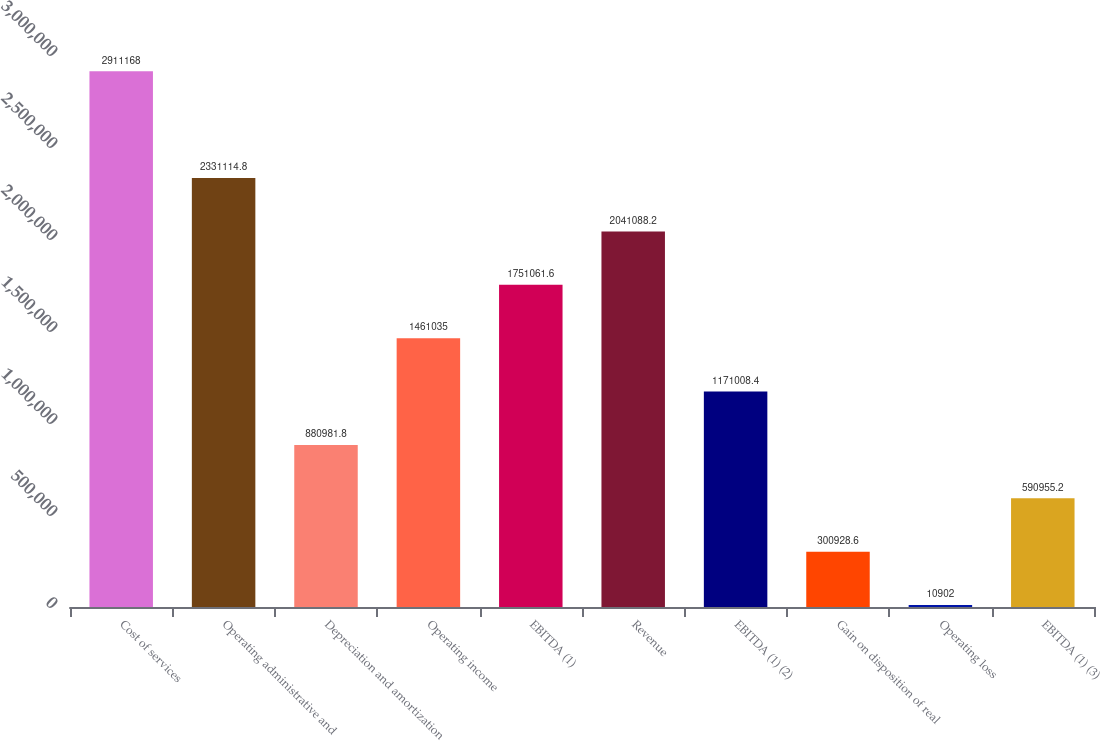Convert chart to OTSL. <chart><loc_0><loc_0><loc_500><loc_500><bar_chart><fcel>Cost of services<fcel>Operating administrative and<fcel>Depreciation and amortization<fcel>Operating income<fcel>EBITDA (1)<fcel>Revenue<fcel>EBITDA (1) (2)<fcel>Gain on disposition of real<fcel>Operating loss<fcel>EBITDA (1) (3)<nl><fcel>2.91117e+06<fcel>2.33111e+06<fcel>880982<fcel>1.46104e+06<fcel>1.75106e+06<fcel>2.04109e+06<fcel>1.17101e+06<fcel>300929<fcel>10902<fcel>590955<nl></chart> 